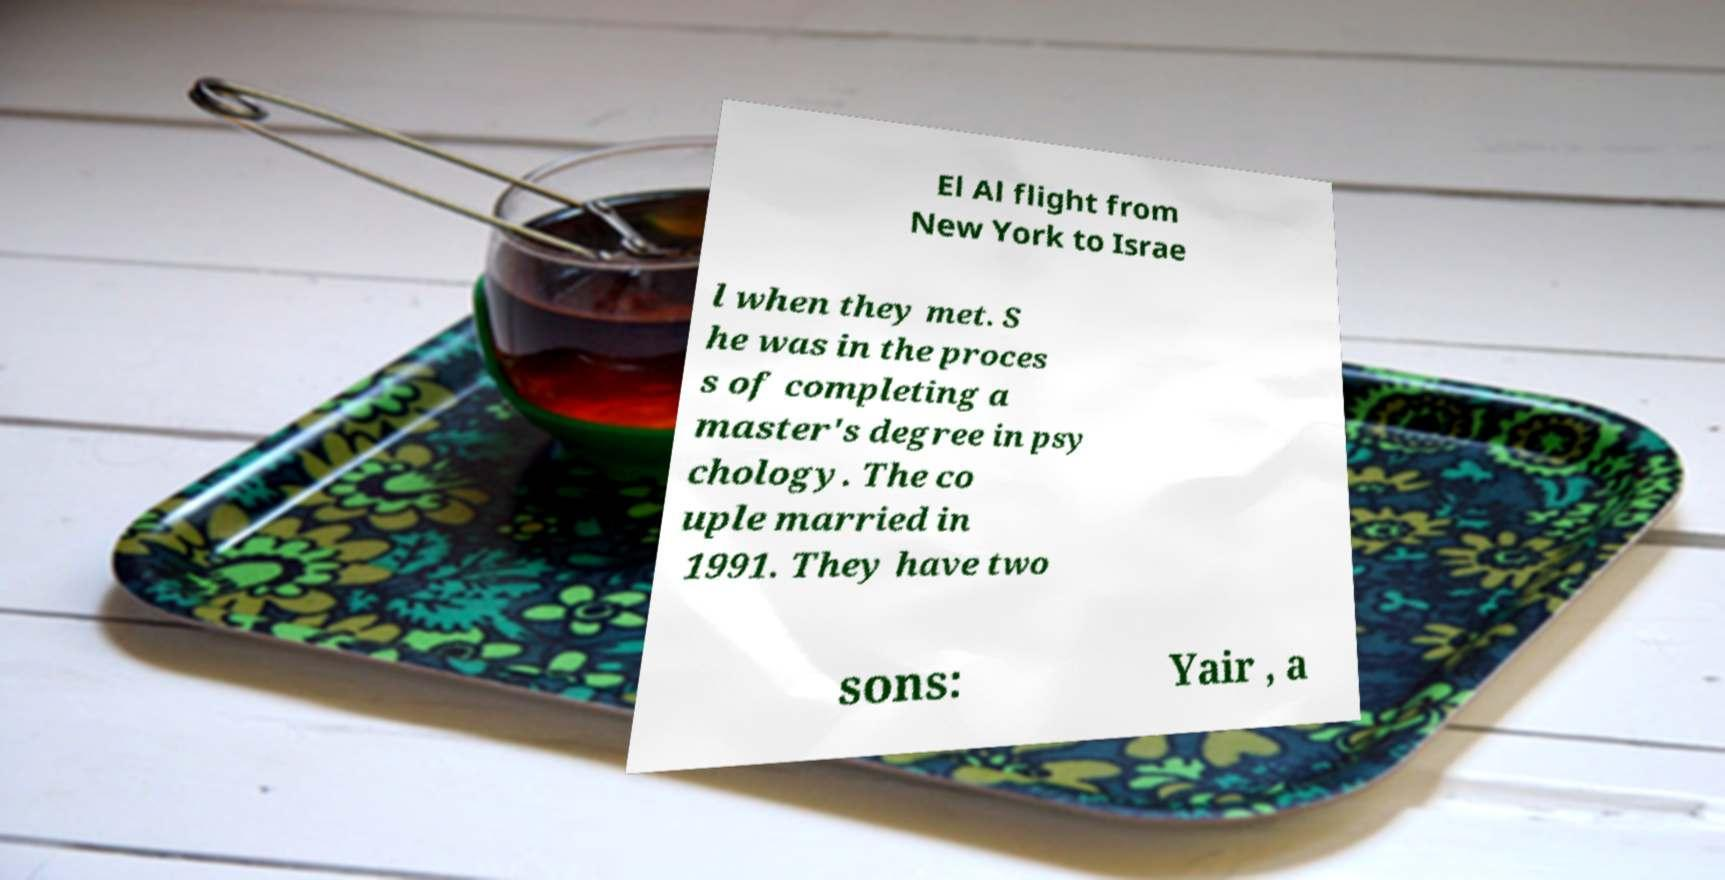Could you assist in decoding the text presented in this image and type it out clearly? El Al flight from New York to Israe l when they met. S he was in the proces s of completing a master's degree in psy chology. The co uple married in 1991. They have two sons: Yair , a 